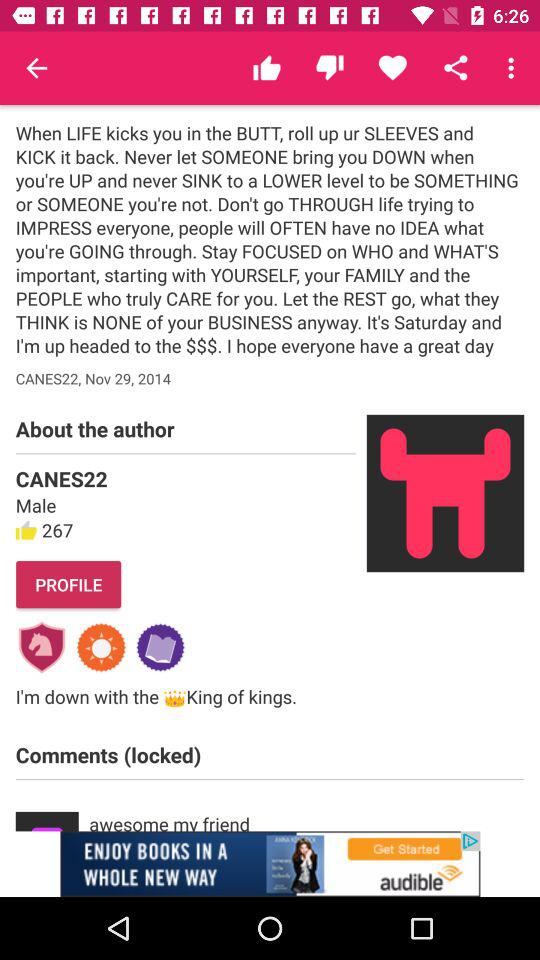How many thumbs up are there on this post?
Answer the question using a single word or phrase. 267 